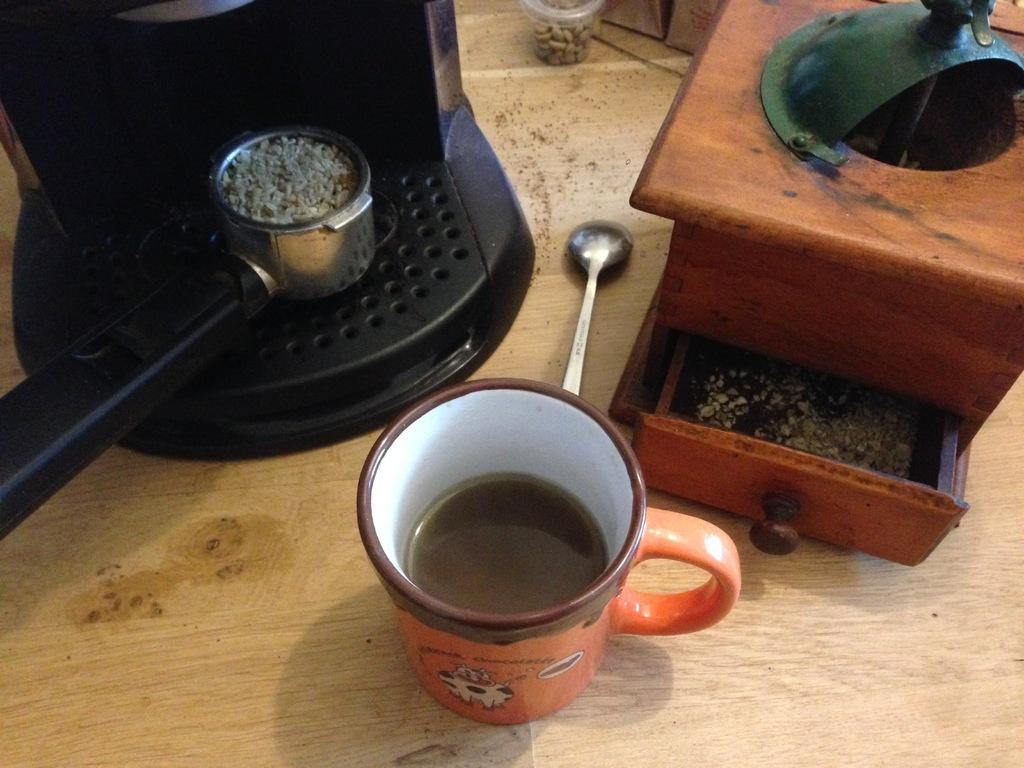What is in the cup that is visible in the image? There is a drink in the cup in the image. What utensil is visible in the image? There is a spoon in the image. What type of container is present in the image? There is a jar in the image. What else can be seen in the image besides the cup, spoon, and jar? There are other objects in the image. On what surface are these items placed? These items are placed on a wooden platform. What type of eggnog is being served in the jar in the image? There is no eggnog present in the image; it only shows a cup with a drink, a spoon, a jar, and other objects on a wooden platform. 